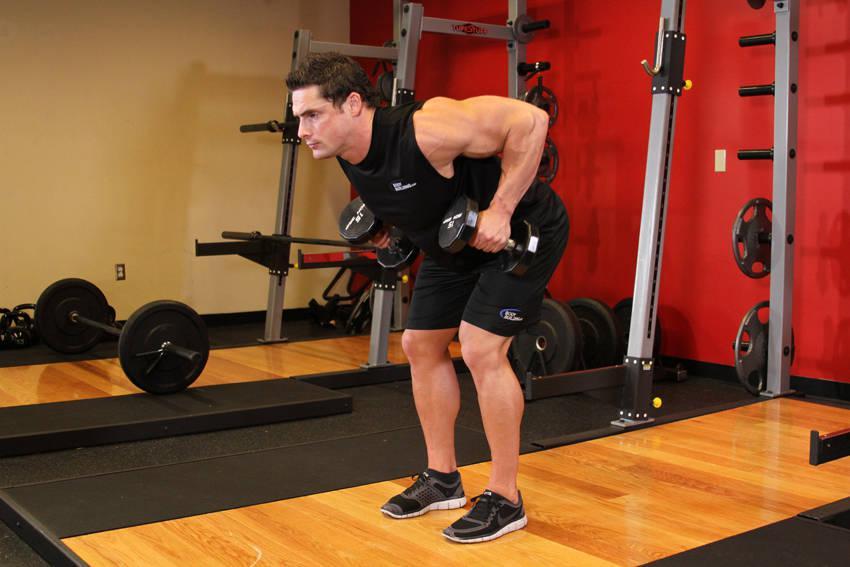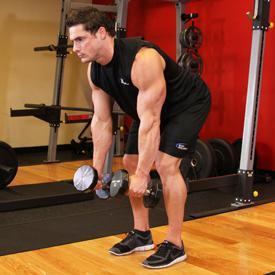The first image is the image on the left, the second image is the image on the right. Assess this claim about the two images: "An image shows a woman bending forward while holding dumbell weights.". Correct or not? Answer yes or no. No. The first image is the image on the left, the second image is the image on the right. For the images displayed, is the sentence "There is no less than one woman lifting weights" factually correct? Answer yes or no. No. 